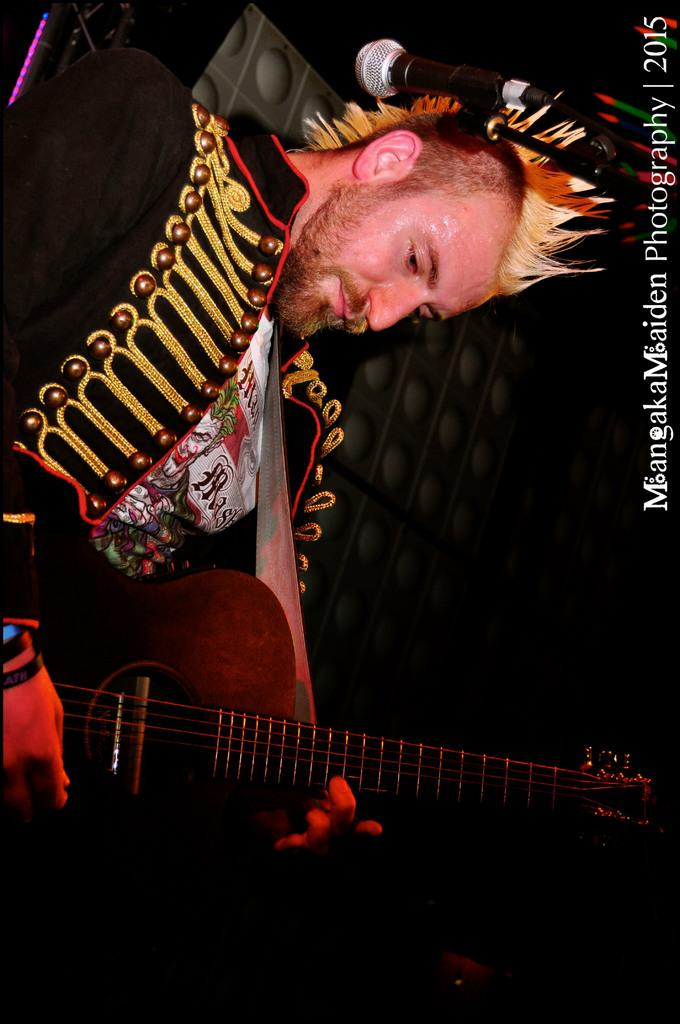What is the person in the image doing? The person is playing a musical instrument in the image. What can be seen on the right side of the image? There is a microphone (mic) and text on the right side of the image. Can you describe the white object visible behind the person? There is a white object visible behind the person, but its specific nature is not clear from the provided facts. How many glasses of wine are visible on the left side of the image? There is no mention of wine or glasses in the provided facts, so it cannot be determined from the image. 